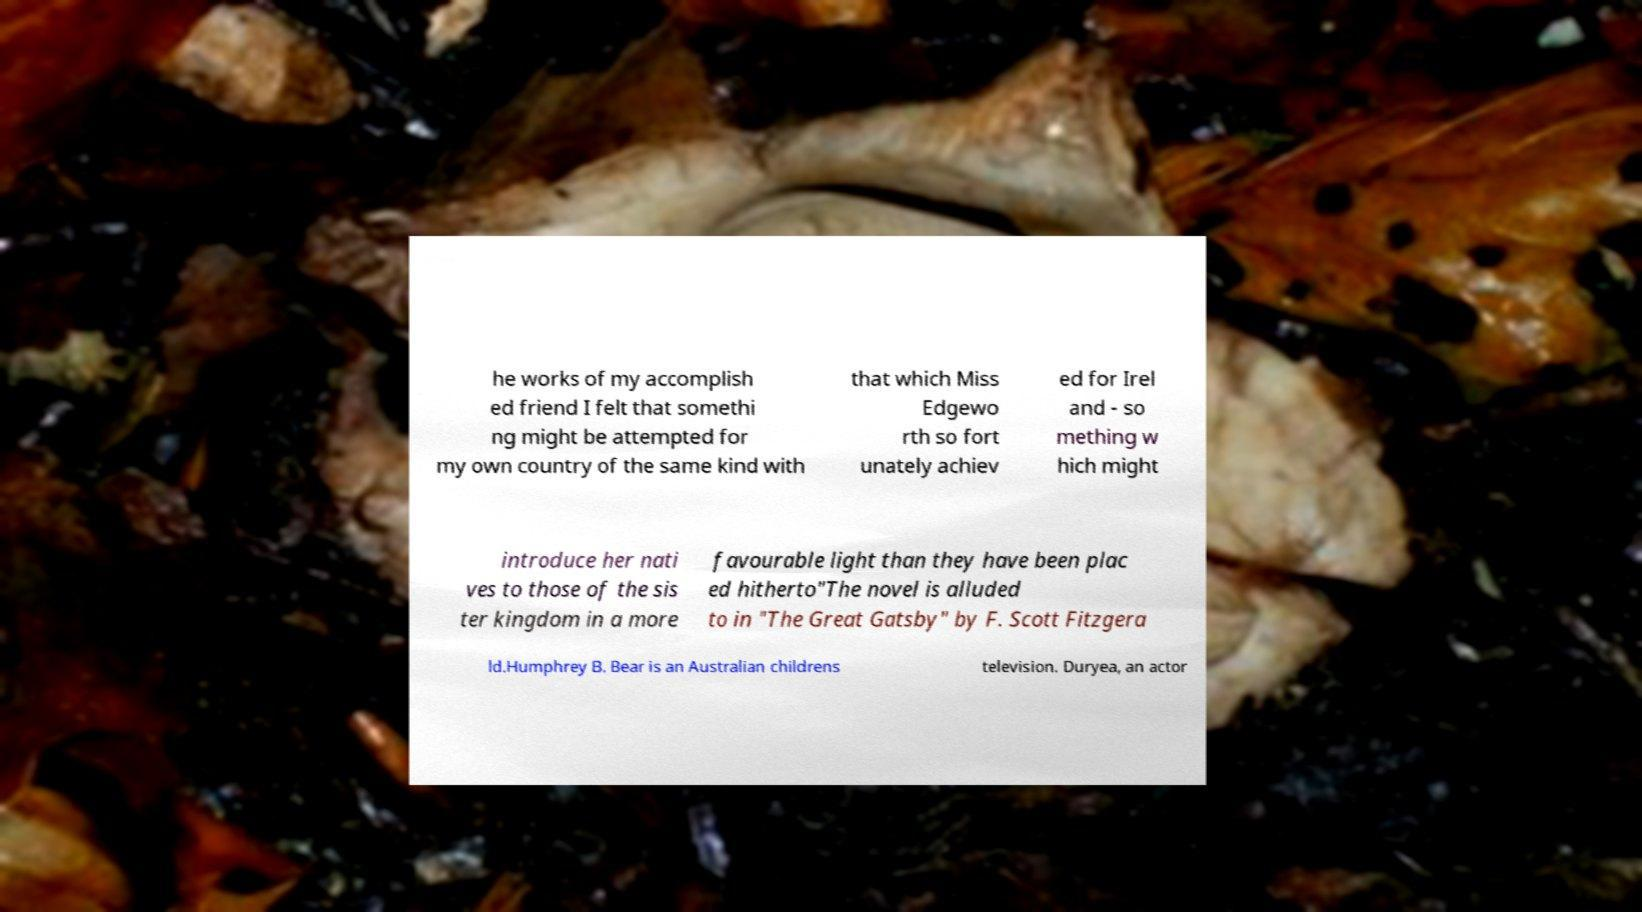Can you accurately transcribe the text from the provided image for me? he works of my accomplish ed friend I felt that somethi ng might be attempted for my own country of the same kind with that which Miss Edgewo rth so fort unately achiev ed for Irel and - so mething w hich might introduce her nati ves to those of the sis ter kingdom in a more favourable light than they have been plac ed hitherto"The novel is alluded to in "The Great Gatsby" by F. Scott Fitzgera ld.Humphrey B. Bear is an Australian childrens television. Duryea, an actor 